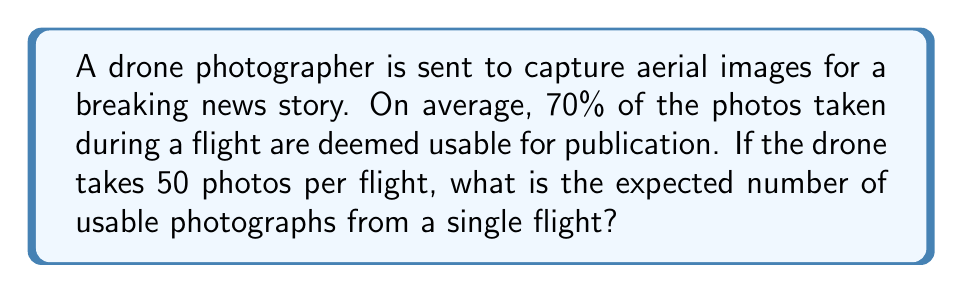Solve this math problem. To solve this problem, we'll use the concept of expected value for a binomial distribution.

Step 1: Identify the random variable
Let X be the number of usable photos from a single flight.

Step 2: Determine the probability distribution
X follows a binomial distribution with parameters:
n = 50 (total number of photos)
p = 0.70 (probability of a photo being usable)

Step 3: Calculate the expected value
For a binomial distribution, the expected value is given by:

$$ E(X) = np $$

Where:
E(X) is the expected value
n is the number of trials
p is the probability of success

Step 4: Plug in the values
$$ E(X) = 50 \times 0.70 $$

Step 5: Compute the result
$$ E(X) = 35 $$

Therefore, the expected number of usable drone photographs from a single flight is 35.
Answer: 35 photos 